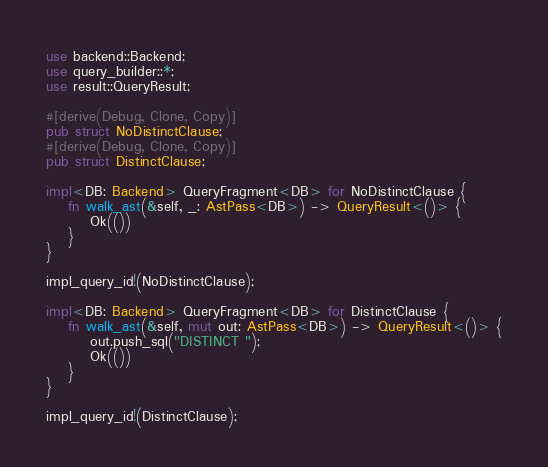Convert code to text. <code><loc_0><loc_0><loc_500><loc_500><_Rust_>use backend::Backend;
use query_builder::*;
use result::QueryResult;

#[derive(Debug, Clone, Copy)]
pub struct NoDistinctClause;
#[derive(Debug, Clone, Copy)]
pub struct DistinctClause;

impl<DB: Backend> QueryFragment<DB> for NoDistinctClause {
    fn walk_ast(&self, _: AstPass<DB>) -> QueryResult<()> {
        Ok(())
    }
}

impl_query_id!(NoDistinctClause);

impl<DB: Backend> QueryFragment<DB> for DistinctClause {
    fn walk_ast(&self, mut out: AstPass<DB>) -> QueryResult<()> {
        out.push_sql("DISTINCT ");
        Ok(())
    }
}

impl_query_id!(DistinctClause);
</code> 